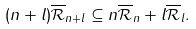Convert formula to latex. <formula><loc_0><loc_0><loc_500><loc_500>( n + l ) \overline { \mathcal { R } } _ { n + l } \subseteq n \overline { \mathcal { R } } _ { n } + l \overline { \mathcal { R } } _ { l } .</formula> 